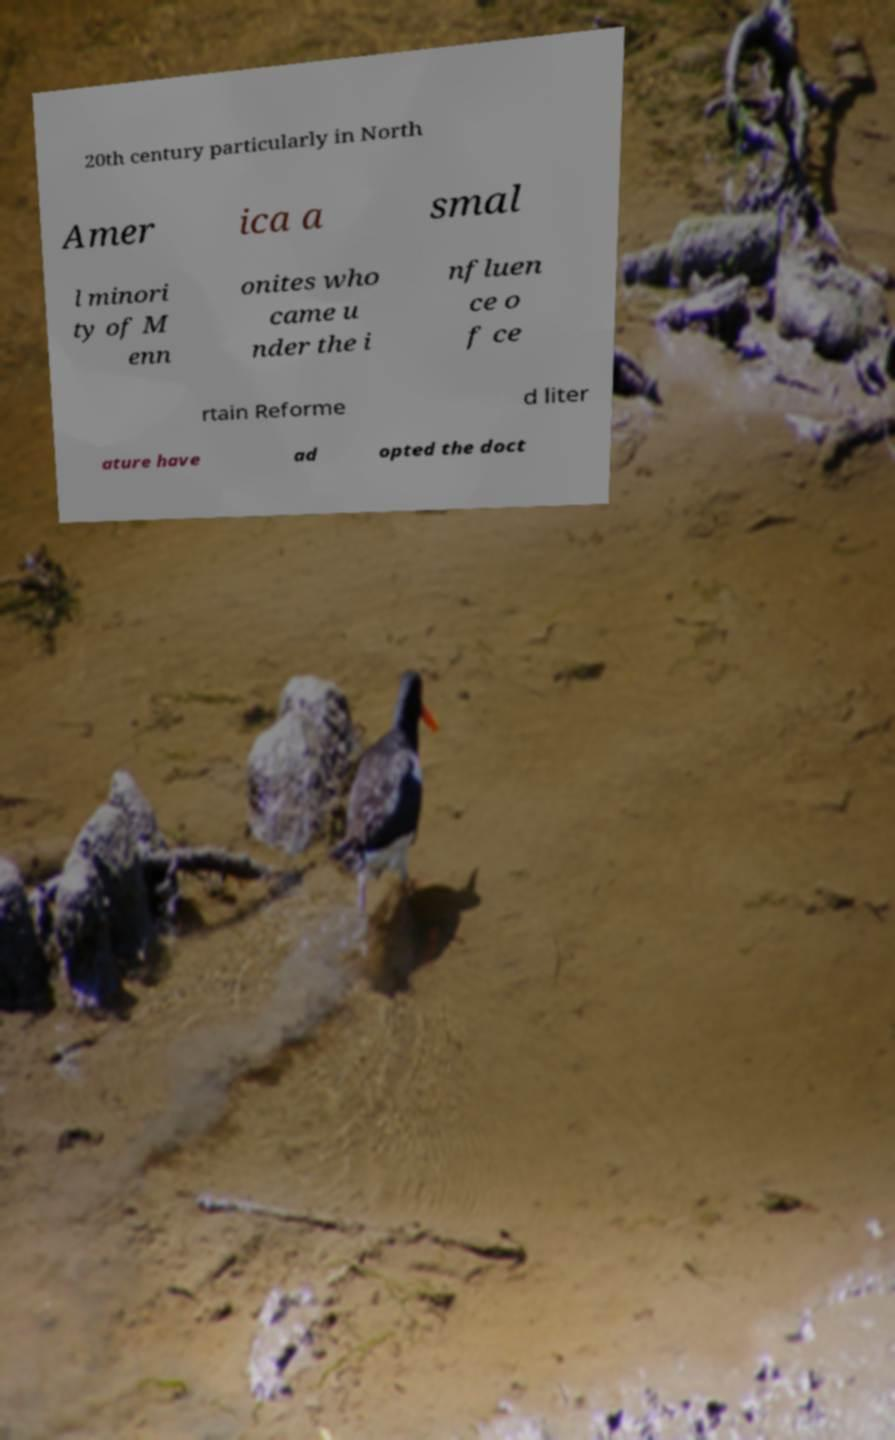For documentation purposes, I need the text within this image transcribed. Could you provide that? 20th century particularly in North Amer ica a smal l minori ty of M enn onites who came u nder the i nfluen ce o f ce rtain Reforme d liter ature have ad opted the doct 